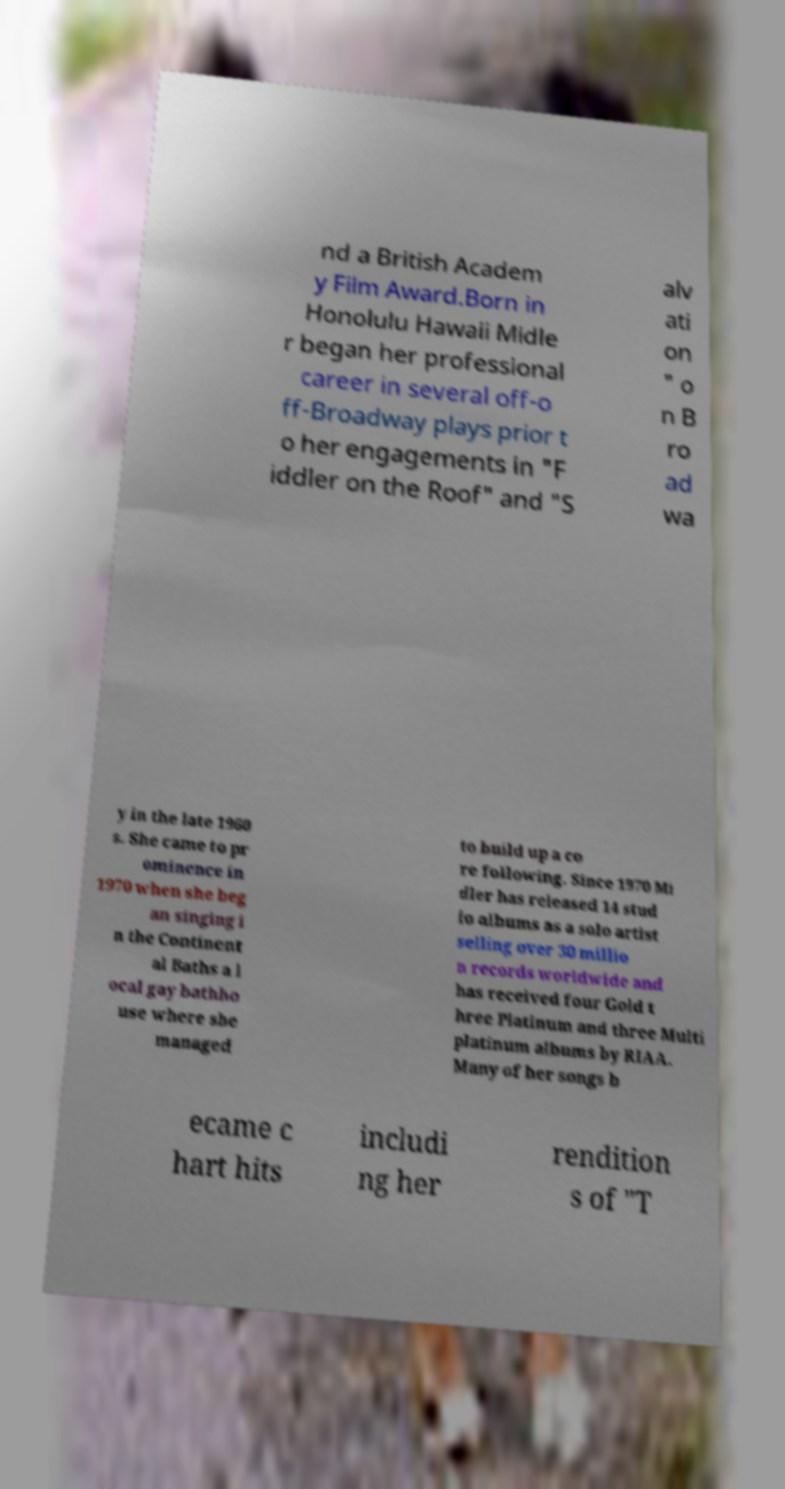Can you accurately transcribe the text from the provided image for me? nd a British Academ y Film Award.Born in Honolulu Hawaii Midle r began her professional career in several off-o ff-Broadway plays prior t o her engagements in "F iddler on the Roof" and "S alv ati on " o n B ro ad wa y in the late 1960 s. She came to pr ominence in 1970 when she beg an singing i n the Continent al Baths a l ocal gay bathho use where she managed to build up a co re following. Since 1970 Mi dler has released 14 stud io albums as a solo artist selling over 30 millio n records worldwide and has received four Gold t hree Platinum and three Multi platinum albums by RIAA. Many of her songs b ecame c hart hits includi ng her rendition s of "T 